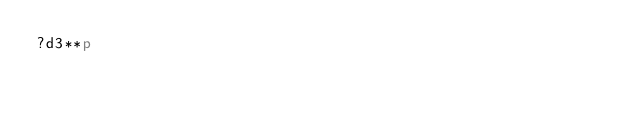<code> <loc_0><loc_0><loc_500><loc_500><_dc_>?d3**p</code> 